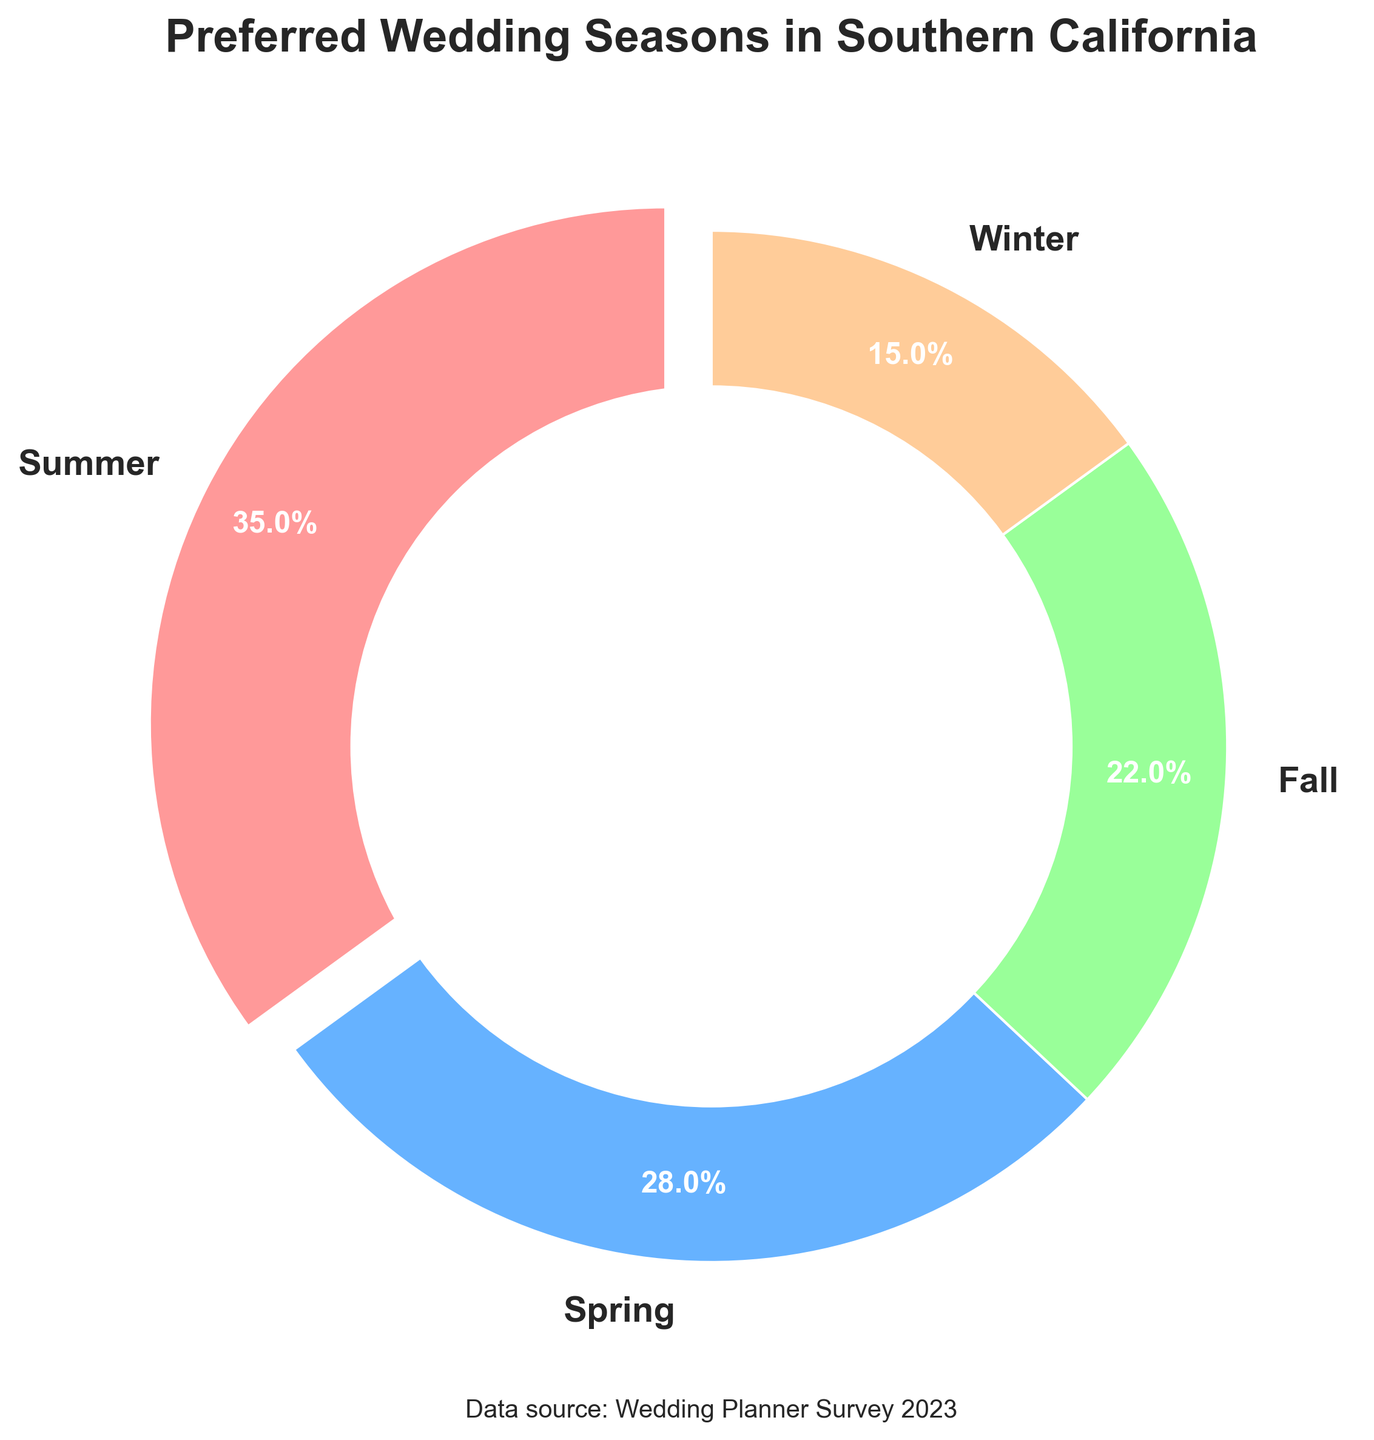What is the most preferred wedding season in Southern California? The largest segment of the pie chart represents the most preferred wedding season. In this case, Summer has the largest percentage at 35%.
Answer: Summer What is the least preferred wedding season in Southern California? The smallest segment of the pie chart indicates the least preferred wedding season. Winter has the smallest percentage at 15%.
Answer: Winter How much more popular is Summer compared to Fall? Summer has a percentage of 35% and Fall has 22%. The difference in their percentages is 35% - 22% = 13%.
Answer: 13% Which seasons combined account for less than half of the preferences? Adding the percentages for Fall (22%) and Winter (15%) gives 22% + 15% = 37%, which is less than 50%.
Answer: Fall and Winter By how much do Spring and Fall differ in their preference percentages? Spring has a percentage of 28% and Fall has 22%. The difference is 28% - 22% = 6%.
Answer: 6% What are the colors used to represent Spring and Fall? The colors in the pie chart for Spring and Fall segments are visually distinguishable. Spring is represented by a light blue and Fall by a light green.
Answer: Light blue for Spring and light green for Fall What is the total percentage of Spring and Winter combined? Adding the percentages for Spring (28%) and Winter (15%) gives 28% + 15% = 43%.
Answer: 43% Which season shows a noticeable separation from the pie chart’s center? The season segment that is slightly separated is exploded for emphasis, which in this case, is Summer.
Answer: Summer Which two seasons have the most similar preference percentages? Comparing the percentages, Spring (28%) and Fall (22%) have the closest values, with a difference of only 6%.
Answer: Spring and Fall What percentage of couples prefer Fall and Winter seasons together? Adding the percentages for Fall (22%) and Winter (15%) gives 22% + 15% = 37%.
Answer: 37% 